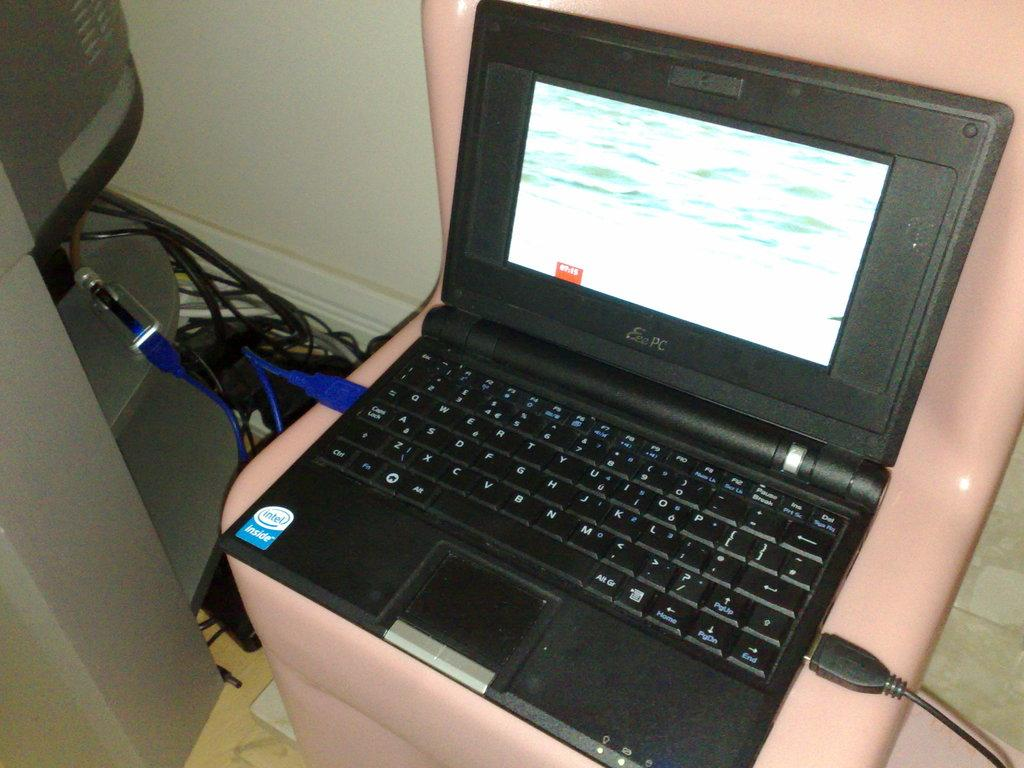<image>
Describe the image concisely. a laptop with the words intel inside on the bottom left 